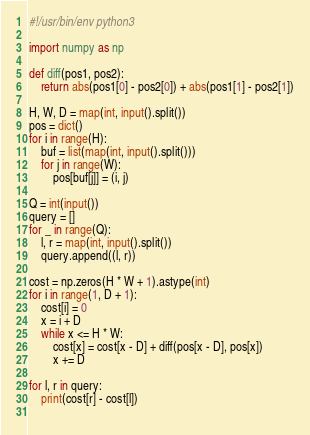<code> <loc_0><loc_0><loc_500><loc_500><_Python_>#!/usr/bin/env python3

import numpy as np

def diff(pos1, pos2):
    return abs(pos1[0] - pos2[0]) + abs(pos1[1] - pos2[1])

H, W, D = map(int, input().split())
pos = dict()
for i in range(H):
    buf = list(map(int, input().split()))
    for j in range(W):
        pos[buf[j]] = (i, j)
        
Q = int(input())
query = []
for _ in range(Q):
    l, r = map(int, input().split())
    query.append((l, r))
        
cost = np.zeros(H * W + 1).astype(int)
for i in range(1, D + 1):
    cost[i] = 0
    x = i + D
    while x <= H * W:
        cost[x] = cost[x - D] + diff(pos[x - D], pos[x])
        x += D
        
for l, r in query:
    print(cost[r] - cost[l])
    </code> 